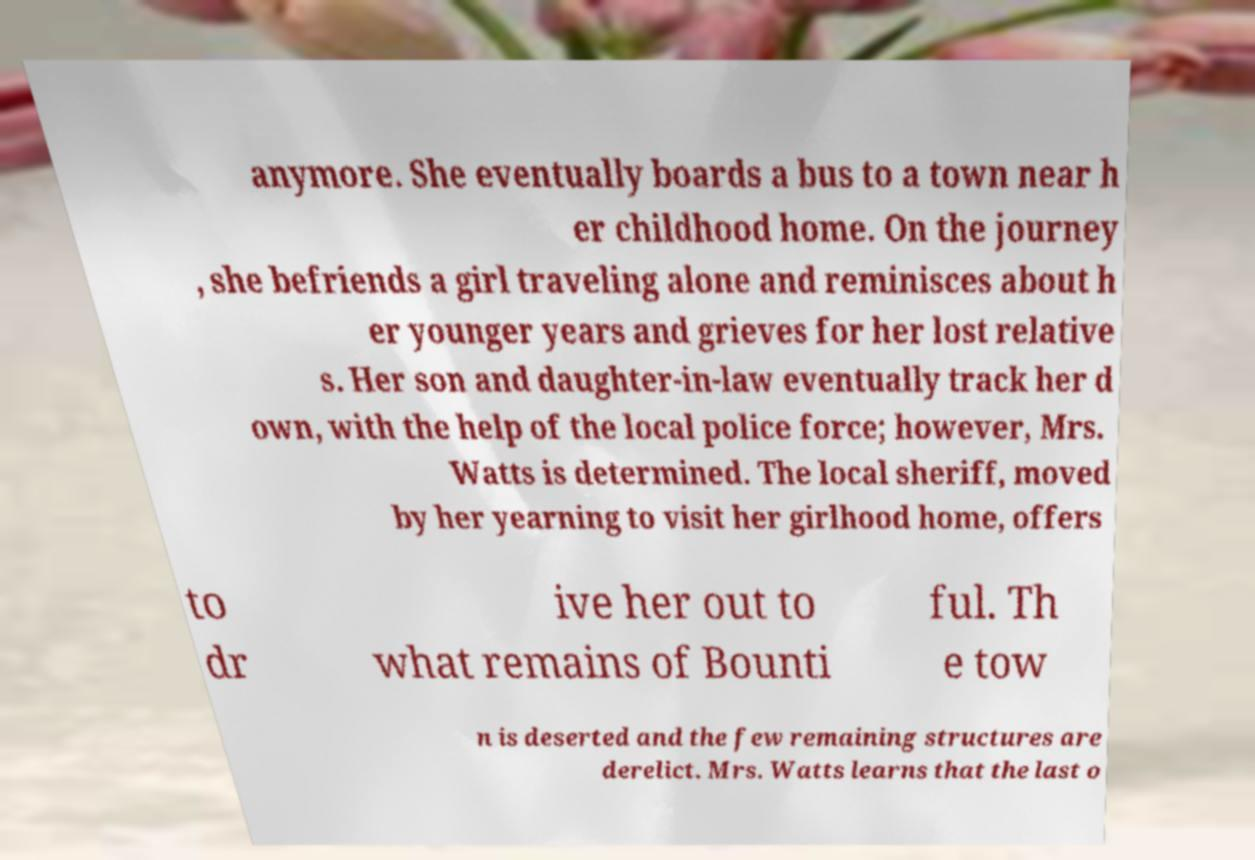For documentation purposes, I need the text within this image transcribed. Could you provide that? anymore. She eventually boards a bus to a town near h er childhood home. On the journey , she befriends a girl traveling alone and reminisces about h er younger years and grieves for her lost relative s. Her son and daughter-in-law eventually track her d own, with the help of the local police force; however, Mrs. Watts is determined. The local sheriff, moved by her yearning to visit her girlhood home, offers to dr ive her out to what remains of Bounti ful. Th e tow n is deserted and the few remaining structures are derelict. Mrs. Watts learns that the last o 